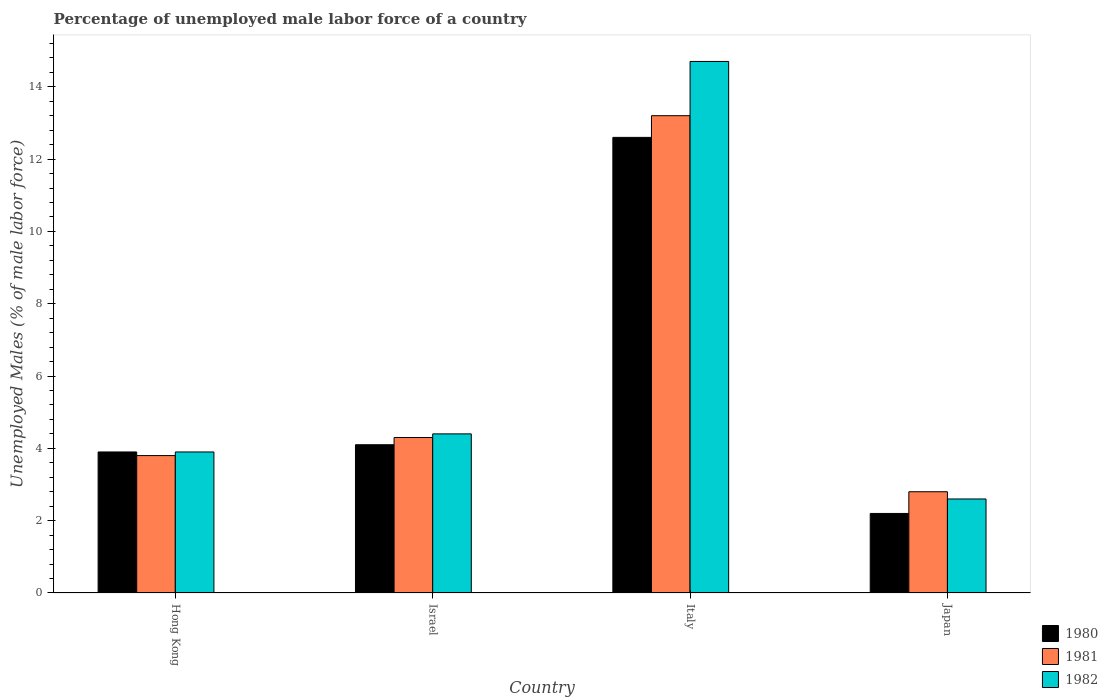How many groups of bars are there?
Give a very brief answer. 4. Are the number of bars on each tick of the X-axis equal?
Keep it short and to the point. Yes. How many bars are there on the 1st tick from the right?
Make the answer very short. 3. What is the label of the 1st group of bars from the left?
Offer a very short reply. Hong Kong. What is the percentage of unemployed male labor force in 1982 in Hong Kong?
Ensure brevity in your answer.  3.9. Across all countries, what is the maximum percentage of unemployed male labor force in 1980?
Provide a succinct answer. 12.6. Across all countries, what is the minimum percentage of unemployed male labor force in 1981?
Offer a terse response. 2.8. In which country was the percentage of unemployed male labor force in 1980 maximum?
Your answer should be very brief. Italy. In which country was the percentage of unemployed male labor force in 1981 minimum?
Keep it short and to the point. Japan. What is the total percentage of unemployed male labor force in 1980 in the graph?
Provide a succinct answer. 22.8. What is the difference between the percentage of unemployed male labor force in 1982 in Italy and that in Japan?
Offer a very short reply. 12.1. What is the difference between the percentage of unemployed male labor force in 1980 in Hong Kong and the percentage of unemployed male labor force in 1981 in Israel?
Keep it short and to the point. -0.4. What is the average percentage of unemployed male labor force in 1981 per country?
Offer a very short reply. 6.02. What is the difference between the percentage of unemployed male labor force of/in 1982 and percentage of unemployed male labor force of/in 1981 in Hong Kong?
Provide a short and direct response. 0.1. In how many countries, is the percentage of unemployed male labor force in 1982 greater than 2.8 %?
Your answer should be very brief. 3. What is the ratio of the percentage of unemployed male labor force in 1980 in Israel to that in Italy?
Your response must be concise. 0.33. Is the percentage of unemployed male labor force in 1980 in Hong Kong less than that in Italy?
Give a very brief answer. Yes. Is the difference between the percentage of unemployed male labor force in 1982 in Israel and Italy greater than the difference between the percentage of unemployed male labor force in 1981 in Israel and Italy?
Make the answer very short. No. What is the difference between the highest and the second highest percentage of unemployed male labor force in 1982?
Provide a short and direct response. -0.5. What is the difference between the highest and the lowest percentage of unemployed male labor force in 1981?
Your answer should be very brief. 10.4. In how many countries, is the percentage of unemployed male labor force in 1982 greater than the average percentage of unemployed male labor force in 1982 taken over all countries?
Your answer should be compact. 1. Is the sum of the percentage of unemployed male labor force in 1982 in Israel and Italy greater than the maximum percentage of unemployed male labor force in 1981 across all countries?
Provide a short and direct response. Yes. What does the 3rd bar from the right in Italy represents?
Keep it short and to the point. 1980. Is it the case that in every country, the sum of the percentage of unemployed male labor force in 1980 and percentage of unemployed male labor force in 1981 is greater than the percentage of unemployed male labor force in 1982?
Keep it short and to the point. Yes. Are all the bars in the graph horizontal?
Offer a terse response. No. How many countries are there in the graph?
Offer a terse response. 4. Are the values on the major ticks of Y-axis written in scientific E-notation?
Your answer should be compact. No. How are the legend labels stacked?
Give a very brief answer. Vertical. What is the title of the graph?
Keep it short and to the point. Percentage of unemployed male labor force of a country. What is the label or title of the X-axis?
Provide a short and direct response. Country. What is the label or title of the Y-axis?
Provide a succinct answer. Unemployed Males (% of male labor force). What is the Unemployed Males (% of male labor force) in 1980 in Hong Kong?
Provide a short and direct response. 3.9. What is the Unemployed Males (% of male labor force) of 1981 in Hong Kong?
Offer a very short reply. 3.8. What is the Unemployed Males (% of male labor force) in 1982 in Hong Kong?
Ensure brevity in your answer.  3.9. What is the Unemployed Males (% of male labor force) of 1980 in Israel?
Offer a very short reply. 4.1. What is the Unemployed Males (% of male labor force) of 1981 in Israel?
Your answer should be very brief. 4.3. What is the Unemployed Males (% of male labor force) of 1982 in Israel?
Offer a very short reply. 4.4. What is the Unemployed Males (% of male labor force) in 1980 in Italy?
Your answer should be very brief. 12.6. What is the Unemployed Males (% of male labor force) in 1981 in Italy?
Your answer should be very brief. 13.2. What is the Unemployed Males (% of male labor force) in 1982 in Italy?
Your answer should be very brief. 14.7. What is the Unemployed Males (% of male labor force) of 1980 in Japan?
Ensure brevity in your answer.  2.2. What is the Unemployed Males (% of male labor force) in 1981 in Japan?
Offer a very short reply. 2.8. What is the Unemployed Males (% of male labor force) of 1982 in Japan?
Your answer should be compact. 2.6. Across all countries, what is the maximum Unemployed Males (% of male labor force) of 1980?
Keep it short and to the point. 12.6. Across all countries, what is the maximum Unemployed Males (% of male labor force) in 1981?
Provide a short and direct response. 13.2. Across all countries, what is the maximum Unemployed Males (% of male labor force) in 1982?
Offer a very short reply. 14.7. Across all countries, what is the minimum Unemployed Males (% of male labor force) in 1980?
Your answer should be compact. 2.2. Across all countries, what is the minimum Unemployed Males (% of male labor force) of 1981?
Your answer should be compact. 2.8. Across all countries, what is the minimum Unemployed Males (% of male labor force) of 1982?
Your response must be concise. 2.6. What is the total Unemployed Males (% of male labor force) of 1980 in the graph?
Your answer should be compact. 22.8. What is the total Unemployed Males (% of male labor force) in 1981 in the graph?
Offer a terse response. 24.1. What is the total Unemployed Males (% of male labor force) of 1982 in the graph?
Ensure brevity in your answer.  25.6. What is the difference between the Unemployed Males (% of male labor force) of 1981 in Hong Kong and that in Italy?
Ensure brevity in your answer.  -9.4. What is the difference between the Unemployed Males (% of male labor force) in 1982 in Hong Kong and that in Italy?
Give a very brief answer. -10.8. What is the difference between the Unemployed Males (% of male labor force) in 1980 in Israel and that in Italy?
Your answer should be compact. -8.5. What is the difference between the Unemployed Males (% of male labor force) in 1981 in Israel and that in Italy?
Make the answer very short. -8.9. What is the difference between the Unemployed Males (% of male labor force) of 1982 in Israel and that in Italy?
Ensure brevity in your answer.  -10.3. What is the difference between the Unemployed Males (% of male labor force) of 1980 in Israel and that in Japan?
Ensure brevity in your answer.  1.9. What is the difference between the Unemployed Males (% of male labor force) in 1981 in Israel and that in Japan?
Keep it short and to the point. 1.5. What is the difference between the Unemployed Males (% of male labor force) of 1982 in Italy and that in Japan?
Your response must be concise. 12.1. What is the difference between the Unemployed Males (% of male labor force) in 1980 in Hong Kong and the Unemployed Males (% of male labor force) in 1981 in Italy?
Your answer should be compact. -9.3. What is the difference between the Unemployed Males (% of male labor force) of 1980 in Hong Kong and the Unemployed Males (% of male labor force) of 1982 in Italy?
Keep it short and to the point. -10.8. What is the difference between the Unemployed Males (% of male labor force) in 1980 in Hong Kong and the Unemployed Males (% of male labor force) in 1981 in Japan?
Make the answer very short. 1.1. What is the difference between the Unemployed Males (% of male labor force) of 1981 in Hong Kong and the Unemployed Males (% of male labor force) of 1982 in Japan?
Provide a short and direct response. 1.2. What is the difference between the Unemployed Males (% of male labor force) of 1981 in Israel and the Unemployed Males (% of male labor force) of 1982 in Japan?
Keep it short and to the point. 1.7. What is the difference between the Unemployed Males (% of male labor force) of 1980 in Italy and the Unemployed Males (% of male labor force) of 1981 in Japan?
Offer a terse response. 9.8. What is the average Unemployed Males (% of male labor force) of 1980 per country?
Your answer should be very brief. 5.7. What is the average Unemployed Males (% of male labor force) in 1981 per country?
Keep it short and to the point. 6.03. What is the average Unemployed Males (% of male labor force) of 1982 per country?
Give a very brief answer. 6.4. What is the difference between the Unemployed Males (% of male labor force) of 1981 and Unemployed Males (% of male labor force) of 1982 in Hong Kong?
Offer a very short reply. -0.1. What is the difference between the Unemployed Males (% of male labor force) of 1980 and Unemployed Males (% of male labor force) of 1982 in Israel?
Give a very brief answer. -0.3. What is the difference between the Unemployed Males (% of male labor force) in 1981 and Unemployed Males (% of male labor force) in 1982 in Italy?
Provide a succinct answer. -1.5. What is the difference between the Unemployed Males (% of male labor force) of 1980 and Unemployed Males (% of male labor force) of 1981 in Japan?
Your answer should be very brief. -0.6. What is the difference between the Unemployed Males (% of male labor force) in 1981 and Unemployed Males (% of male labor force) in 1982 in Japan?
Give a very brief answer. 0.2. What is the ratio of the Unemployed Males (% of male labor force) of 1980 in Hong Kong to that in Israel?
Provide a succinct answer. 0.95. What is the ratio of the Unemployed Males (% of male labor force) in 1981 in Hong Kong to that in Israel?
Ensure brevity in your answer.  0.88. What is the ratio of the Unemployed Males (% of male labor force) in 1982 in Hong Kong to that in Israel?
Provide a short and direct response. 0.89. What is the ratio of the Unemployed Males (% of male labor force) in 1980 in Hong Kong to that in Italy?
Provide a succinct answer. 0.31. What is the ratio of the Unemployed Males (% of male labor force) in 1981 in Hong Kong to that in Italy?
Provide a short and direct response. 0.29. What is the ratio of the Unemployed Males (% of male labor force) in 1982 in Hong Kong to that in Italy?
Give a very brief answer. 0.27. What is the ratio of the Unemployed Males (% of male labor force) of 1980 in Hong Kong to that in Japan?
Offer a terse response. 1.77. What is the ratio of the Unemployed Males (% of male labor force) in 1981 in Hong Kong to that in Japan?
Ensure brevity in your answer.  1.36. What is the ratio of the Unemployed Males (% of male labor force) of 1982 in Hong Kong to that in Japan?
Give a very brief answer. 1.5. What is the ratio of the Unemployed Males (% of male labor force) of 1980 in Israel to that in Italy?
Provide a succinct answer. 0.33. What is the ratio of the Unemployed Males (% of male labor force) in 1981 in Israel to that in Italy?
Your response must be concise. 0.33. What is the ratio of the Unemployed Males (% of male labor force) in 1982 in Israel to that in Italy?
Offer a very short reply. 0.3. What is the ratio of the Unemployed Males (% of male labor force) of 1980 in Israel to that in Japan?
Keep it short and to the point. 1.86. What is the ratio of the Unemployed Males (% of male labor force) in 1981 in Israel to that in Japan?
Keep it short and to the point. 1.54. What is the ratio of the Unemployed Males (% of male labor force) of 1982 in Israel to that in Japan?
Offer a terse response. 1.69. What is the ratio of the Unemployed Males (% of male labor force) in 1980 in Italy to that in Japan?
Provide a short and direct response. 5.73. What is the ratio of the Unemployed Males (% of male labor force) of 1981 in Italy to that in Japan?
Keep it short and to the point. 4.71. What is the ratio of the Unemployed Males (% of male labor force) of 1982 in Italy to that in Japan?
Make the answer very short. 5.65. What is the difference between the highest and the lowest Unemployed Males (% of male labor force) of 1980?
Provide a succinct answer. 10.4. What is the difference between the highest and the lowest Unemployed Males (% of male labor force) in 1982?
Your answer should be very brief. 12.1. 